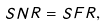<formula> <loc_0><loc_0><loc_500><loc_500>S N R = S F R ,</formula> 